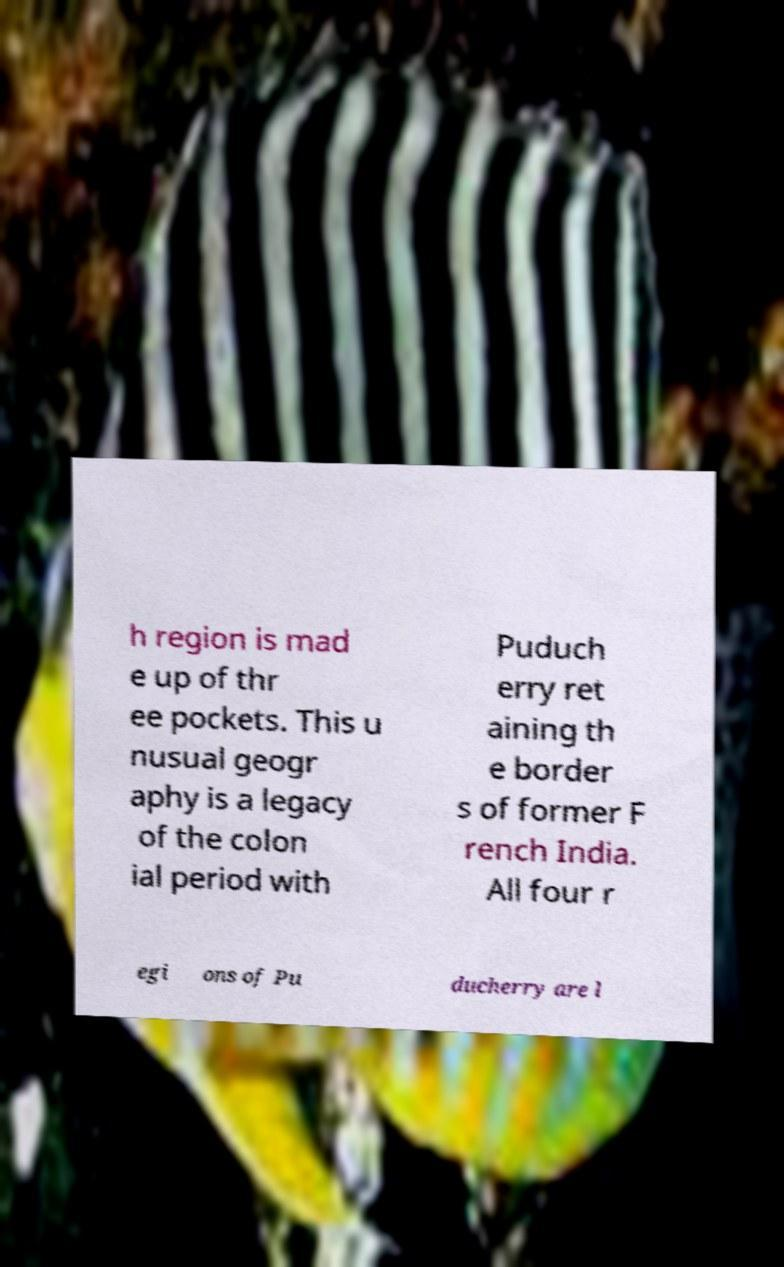Could you assist in decoding the text presented in this image and type it out clearly? h region is mad e up of thr ee pockets. This u nusual geogr aphy is a legacy of the colon ial period with Puduch erry ret aining th e border s of former F rench India. All four r egi ons of Pu ducherry are l 